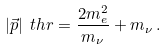<formula> <loc_0><loc_0><loc_500><loc_500>| \vec { p } | _ { \ } t h r = \frac { 2 m _ { e } ^ { 2 } } { m _ { \nu } } + m _ { \nu } \, .</formula> 